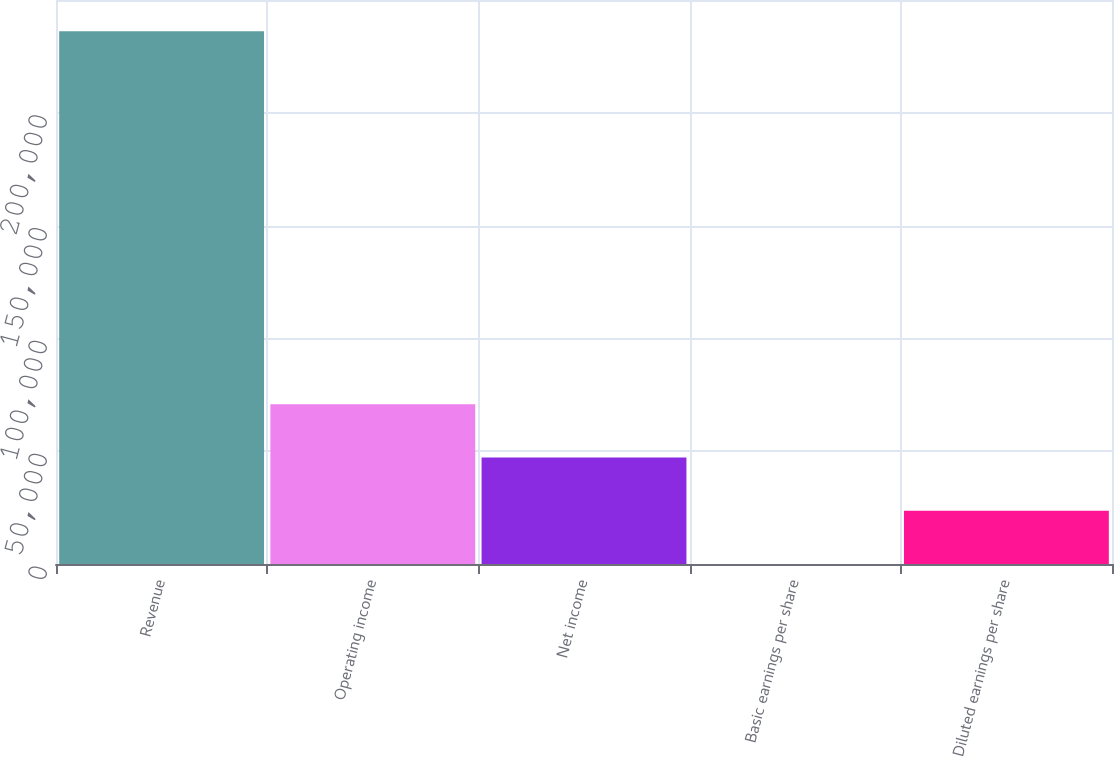Convert chart. <chart><loc_0><loc_0><loc_500><loc_500><bar_chart><fcel>Revenue<fcel>Operating income<fcel>Net income<fcel>Basic earnings per share<fcel>Diluted earnings per share<nl><fcel>236095<fcel>70828.8<fcel>47219.3<fcel>0.38<fcel>23609.8<nl></chart> 